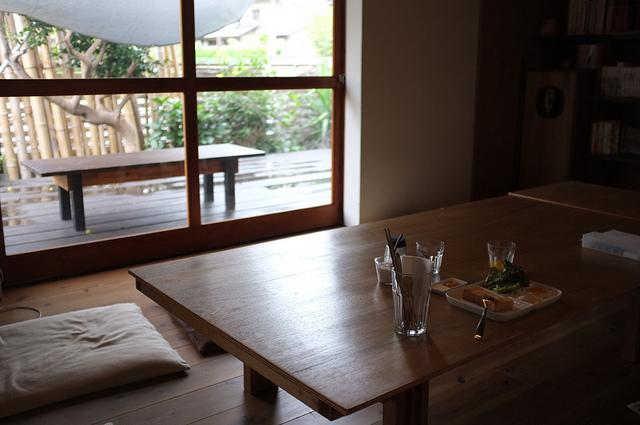What is closest to the left ledge of the table? Please explain your reasoning. glass. Various items are on a table including drinkware. 